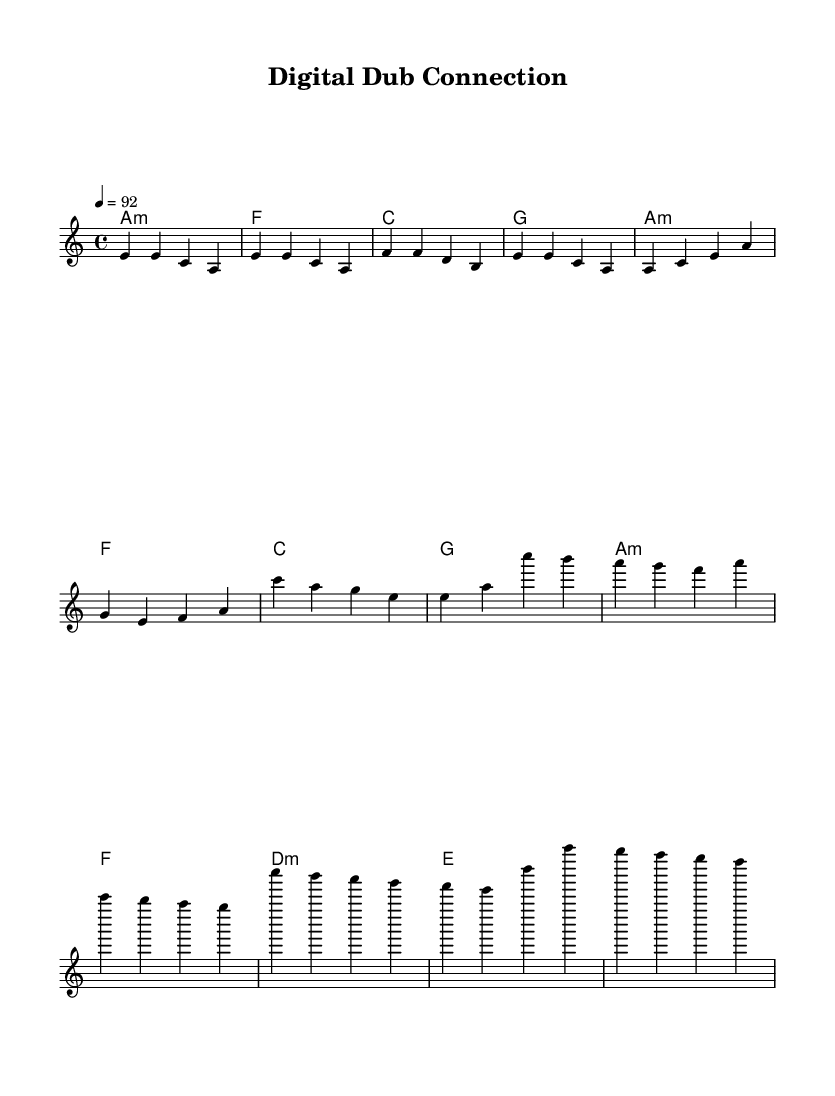What is the key signature of this music? The key signature is A minor, which has no sharps or flats, as indicated in the global section of the code.
Answer: A minor What is the time signature of the piece? The time signature is 4/4, which means there are four beats in a measure and a quarter note gets one beat. This is explicitly stated in the global section.
Answer: 4/4 What is the tempo marking for the song? The tempo marking is 92 beats per minute, which is indicated by the tempo command in the global section of the code.
Answer: 92 How many measures are included in the melody? The melody consists of eight measures, as observed from counting the groups of notes before the repeat. Each line of music contains four measures, and there are two lines.
Answer: 8 What genre does this piece represent? The piece represents modern reggae fusion due to the rhythmic structure and the combination of reggae elements with electronic components suggested by the title "Digital Dub Connection."
Answer: Reggae fusion Which chord is played for the first measure? The first measure features an A minor chord, indicated by the chord name in the harmonies section, which starts off the progression.
Answer: A minor What is the main theme of the lyrics likely to revolve around? The main theme likely revolves around social media's impact, as suggested by the description of the music exploring this concept in modern reggae fusion.
Answer: Social media 